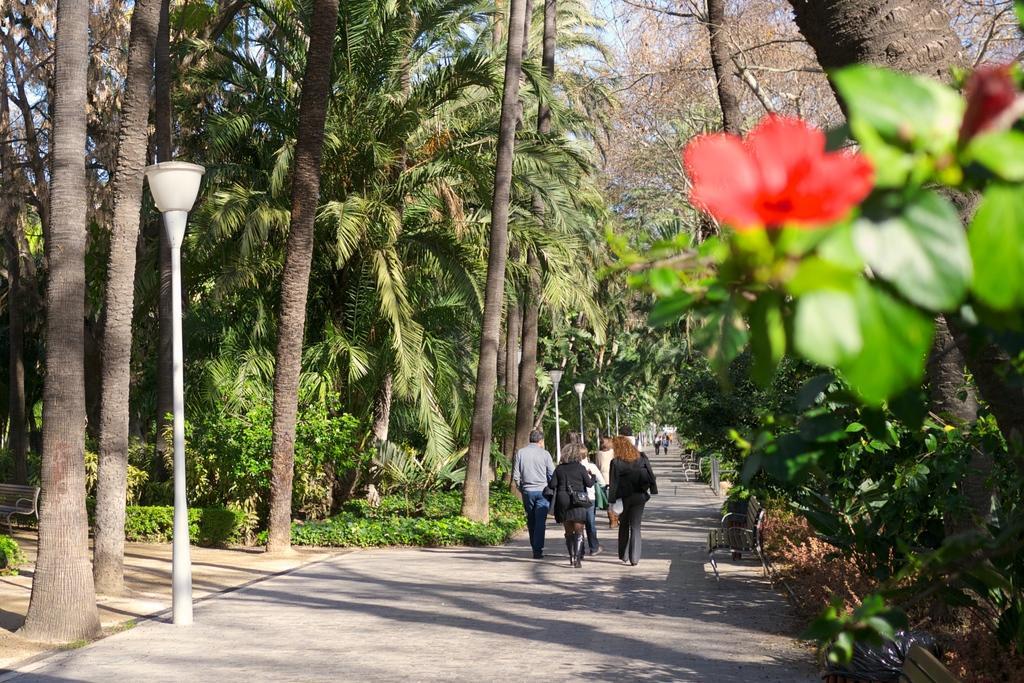Please provide a concise description of this image. In this picture I can see trees and few pole lights and I can see few people walking and I can see flowers and I can see few benches and a blue sky. 